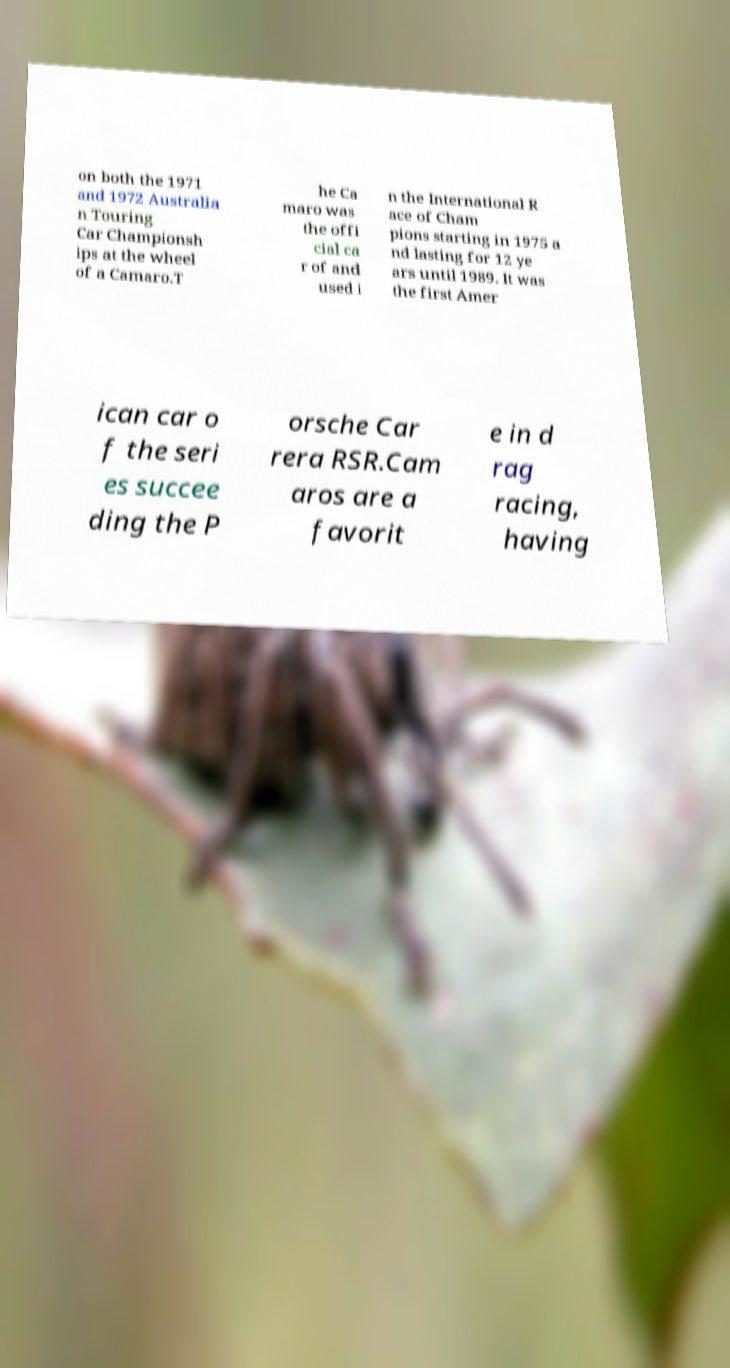There's text embedded in this image that I need extracted. Can you transcribe it verbatim? on both the 1971 and 1972 Australia n Touring Car Championsh ips at the wheel of a Camaro.T he Ca maro was the offi cial ca r of and used i n the International R ace of Cham pions starting in 1975 a nd lasting for 12 ye ars until 1989. It was the first Amer ican car o f the seri es succee ding the P orsche Car rera RSR.Cam aros are a favorit e in d rag racing, having 